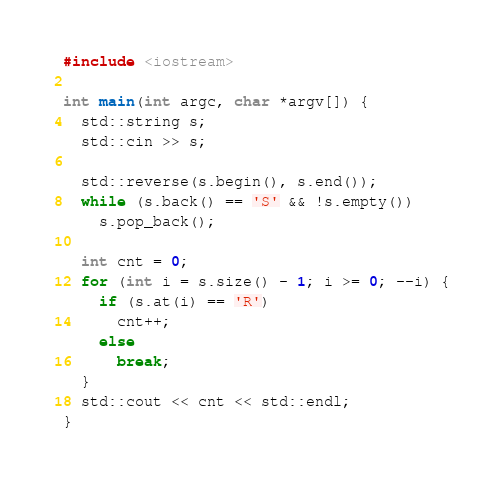Convert code to text. <code><loc_0><loc_0><loc_500><loc_500><_C++_>#include <iostream>

int main(int argc, char *argv[]) {
  std::string s;
  std::cin >> s;

  std::reverse(s.begin(), s.end());
  while (s.back() == 'S' && !s.empty())
    s.pop_back();

  int cnt = 0;
  for (int i = s.size() - 1; i >= 0; --i) {
    if (s.at(i) == 'R')
      cnt++;
    else
      break;
  }
  std::cout << cnt << std::endl;
}
</code> 